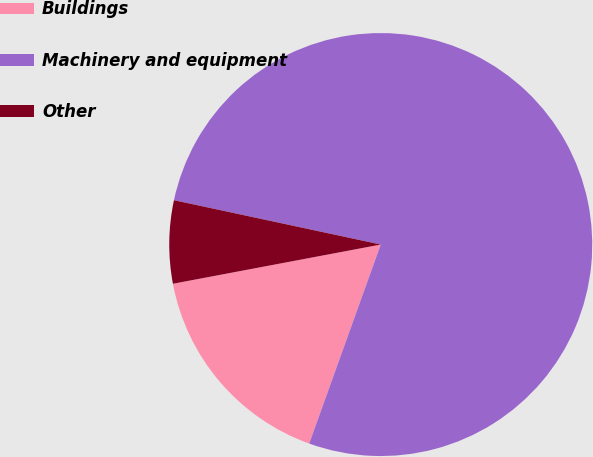Convert chart. <chart><loc_0><loc_0><loc_500><loc_500><pie_chart><fcel>Buildings<fcel>Machinery and equipment<fcel>Other<nl><fcel>16.54%<fcel>77.13%<fcel>6.33%<nl></chart> 